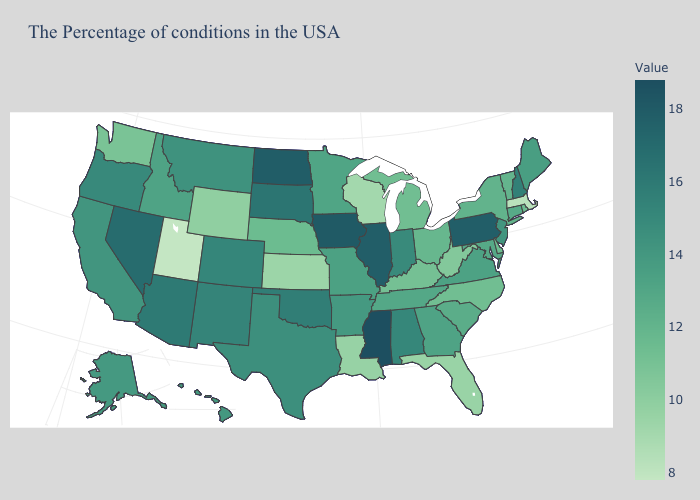Which states have the lowest value in the West?
Write a very short answer. Utah. Which states have the lowest value in the USA?
Give a very brief answer. Utah. Which states hav the highest value in the Northeast?
Write a very short answer. Pennsylvania. Does Utah have the lowest value in the USA?
Write a very short answer. Yes. Does Louisiana have a lower value than Colorado?
Answer briefly. Yes. 